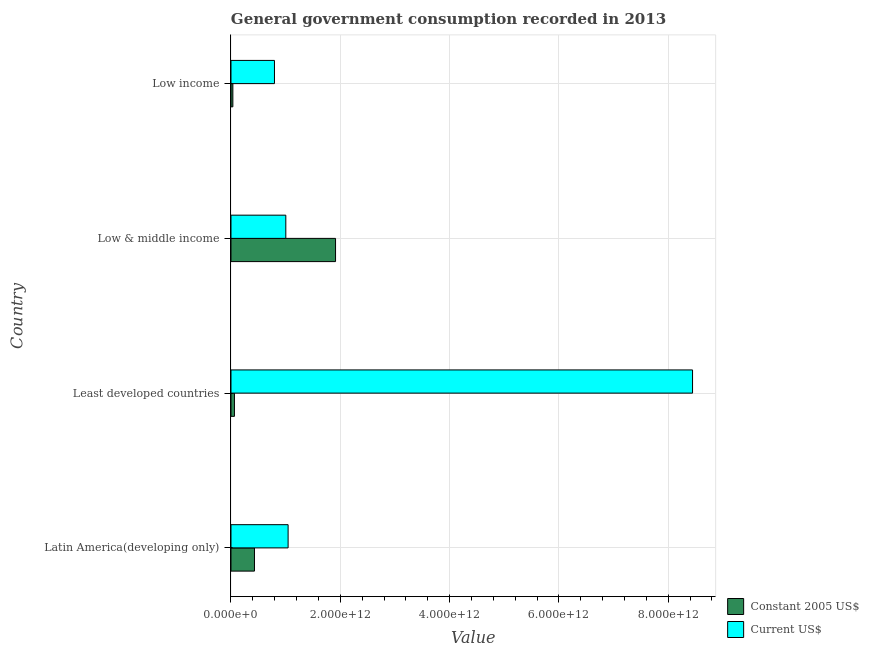Are the number of bars per tick equal to the number of legend labels?
Give a very brief answer. Yes. How many bars are there on the 1st tick from the bottom?
Make the answer very short. 2. What is the label of the 4th group of bars from the top?
Provide a succinct answer. Latin America(developing only). In how many cases, is the number of bars for a given country not equal to the number of legend labels?
Provide a succinct answer. 0. What is the value consumed in constant 2005 us$ in Latin America(developing only)?
Your response must be concise. 4.30e+11. Across all countries, what is the maximum value consumed in constant 2005 us$?
Make the answer very short. 1.91e+12. Across all countries, what is the minimum value consumed in constant 2005 us$?
Offer a very short reply. 3.45e+1. In which country was the value consumed in current us$ maximum?
Give a very brief answer. Least developed countries. What is the total value consumed in constant 2005 us$ in the graph?
Keep it short and to the point. 2.44e+12. What is the difference between the value consumed in current us$ in Latin America(developing only) and that in Low income?
Make the answer very short. 2.50e+11. What is the difference between the value consumed in constant 2005 us$ in Low & middle income and the value consumed in current us$ in Least developed countries?
Provide a short and direct response. -6.53e+12. What is the average value consumed in current us$ per country?
Your answer should be very brief. 2.82e+12. What is the difference between the value consumed in current us$ and value consumed in constant 2005 us$ in Least developed countries?
Your answer should be very brief. 8.38e+12. What is the ratio of the value consumed in current us$ in Least developed countries to that in Low & middle income?
Keep it short and to the point. 8.42. What is the difference between the highest and the second highest value consumed in current us$?
Provide a succinct answer. 7.40e+12. What is the difference between the highest and the lowest value consumed in current us$?
Make the answer very short. 7.65e+12. In how many countries, is the value consumed in current us$ greater than the average value consumed in current us$ taken over all countries?
Make the answer very short. 1. Is the sum of the value consumed in constant 2005 us$ in Low & middle income and Low income greater than the maximum value consumed in current us$ across all countries?
Your answer should be very brief. No. What does the 2nd bar from the top in Least developed countries represents?
Your answer should be very brief. Constant 2005 US$. What does the 1st bar from the bottom in Low & middle income represents?
Make the answer very short. Constant 2005 US$. How many bars are there?
Your response must be concise. 8. How many countries are there in the graph?
Provide a short and direct response. 4. What is the difference between two consecutive major ticks on the X-axis?
Offer a very short reply. 2.00e+12. Are the values on the major ticks of X-axis written in scientific E-notation?
Ensure brevity in your answer.  Yes. Does the graph contain any zero values?
Ensure brevity in your answer.  No. Does the graph contain grids?
Offer a very short reply. Yes. How many legend labels are there?
Your answer should be compact. 2. How are the legend labels stacked?
Give a very brief answer. Vertical. What is the title of the graph?
Offer a terse response. General government consumption recorded in 2013. Does "Broad money growth" appear as one of the legend labels in the graph?
Ensure brevity in your answer.  No. What is the label or title of the X-axis?
Your response must be concise. Value. What is the Value of Constant 2005 US$ in Latin America(developing only)?
Offer a very short reply. 4.30e+11. What is the Value of Current US$ in Latin America(developing only)?
Keep it short and to the point. 1.05e+12. What is the Value in Constant 2005 US$ in Least developed countries?
Make the answer very short. 6.36e+1. What is the Value of Current US$ in Least developed countries?
Keep it short and to the point. 8.45e+12. What is the Value in Constant 2005 US$ in Low & middle income?
Your response must be concise. 1.91e+12. What is the Value in Current US$ in Low & middle income?
Provide a succinct answer. 1.00e+12. What is the Value in Constant 2005 US$ in Low income?
Offer a terse response. 3.45e+1. What is the Value of Current US$ in Low income?
Provide a short and direct response. 7.96e+11. Across all countries, what is the maximum Value of Constant 2005 US$?
Provide a short and direct response. 1.91e+12. Across all countries, what is the maximum Value in Current US$?
Your response must be concise. 8.45e+12. Across all countries, what is the minimum Value in Constant 2005 US$?
Your answer should be compact. 3.45e+1. Across all countries, what is the minimum Value in Current US$?
Provide a succinct answer. 7.96e+11. What is the total Value in Constant 2005 US$ in the graph?
Your response must be concise. 2.44e+12. What is the total Value in Current US$ in the graph?
Ensure brevity in your answer.  1.13e+13. What is the difference between the Value in Constant 2005 US$ in Latin America(developing only) and that in Least developed countries?
Give a very brief answer. 3.66e+11. What is the difference between the Value in Current US$ in Latin America(developing only) and that in Least developed countries?
Offer a very short reply. -7.40e+12. What is the difference between the Value of Constant 2005 US$ in Latin America(developing only) and that in Low & middle income?
Your answer should be compact. -1.48e+12. What is the difference between the Value of Current US$ in Latin America(developing only) and that in Low & middle income?
Your response must be concise. 4.22e+1. What is the difference between the Value in Constant 2005 US$ in Latin America(developing only) and that in Low income?
Your answer should be compact. 3.95e+11. What is the difference between the Value in Current US$ in Latin America(developing only) and that in Low income?
Ensure brevity in your answer.  2.50e+11. What is the difference between the Value of Constant 2005 US$ in Least developed countries and that in Low & middle income?
Provide a short and direct response. -1.85e+12. What is the difference between the Value in Current US$ in Least developed countries and that in Low & middle income?
Offer a terse response. 7.44e+12. What is the difference between the Value of Constant 2005 US$ in Least developed countries and that in Low income?
Keep it short and to the point. 2.91e+1. What is the difference between the Value of Current US$ in Least developed countries and that in Low income?
Make the answer very short. 7.65e+12. What is the difference between the Value of Constant 2005 US$ in Low & middle income and that in Low income?
Your answer should be very brief. 1.88e+12. What is the difference between the Value of Current US$ in Low & middle income and that in Low income?
Give a very brief answer. 2.08e+11. What is the difference between the Value in Constant 2005 US$ in Latin America(developing only) and the Value in Current US$ in Least developed countries?
Your response must be concise. -8.02e+12. What is the difference between the Value of Constant 2005 US$ in Latin America(developing only) and the Value of Current US$ in Low & middle income?
Keep it short and to the point. -5.73e+11. What is the difference between the Value in Constant 2005 US$ in Latin America(developing only) and the Value in Current US$ in Low income?
Make the answer very short. -3.66e+11. What is the difference between the Value of Constant 2005 US$ in Least developed countries and the Value of Current US$ in Low & middle income?
Keep it short and to the point. -9.40e+11. What is the difference between the Value of Constant 2005 US$ in Least developed countries and the Value of Current US$ in Low income?
Provide a succinct answer. -7.32e+11. What is the difference between the Value of Constant 2005 US$ in Low & middle income and the Value of Current US$ in Low income?
Keep it short and to the point. 1.12e+12. What is the average Value of Constant 2005 US$ per country?
Provide a succinct answer. 6.10e+11. What is the average Value in Current US$ per country?
Your answer should be very brief. 2.82e+12. What is the difference between the Value of Constant 2005 US$ and Value of Current US$ in Latin America(developing only)?
Provide a succinct answer. -6.16e+11. What is the difference between the Value of Constant 2005 US$ and Value of Current US$ in Least developed countries?
Your answer should be compact. -8.38e+12. What is the difference between the Value in Constant 2005 US$ and Value in Current US$ in Low & middle income?
Offer a terse response. 9.10e+11. What is the difference between the Value in Constant 2005 US$ and Value in Current US$ in Low income?
Keep it short and to the point. -7.61e+11. What is the ratio of the Value of Constant 2005 US$ in Latin America(developing only) to that in Least developed countries?
Make the answer very short. 6.76. What is the ratio of the Value of Current US$ in Latin America(developing only) to that in Least developed countries?
Offer a terse response. 0.12. What is the ratio of the Value of Constant 2005 US$ in Latin America(developing only) to that in Low & middle income?
Your response must be concise. 0.22. What is the ratio of the Value of Current US$ in Latin America(developing only) to that in Low & middle income?
Your answer should be compact. 1.04. What is the ratio of the Value of Constant 2005 US$ in Latin America(developing only) to that in Low income?
Your response must be concise. 12.47. What is the ratio of the Value of Current US$ in Latin America(developing only) to that in Low income?
Your answer should be very brief. 1.31. What is the ratio of the Value in Constant 2005 US$ in Least developed countries to that in Low & middle income?
Ensure brevity in your answer.  0.03. What is the ratio of the Value in Current US$ in Least developed countries to that in Low & middle income?
Keep it short and to the point. 8.42. What is the ratio of the Value of Constant 2005 US$ in Least developed countries to that in Low income?
Ensure brevity in your answer.  1.84. What is the ratio of the Value in Current US$ in Least developed countries to that in Low income?
Your answer should be very brief. 10.61. What is the ratio of the Value of Constant 2005 US$ in Low & middle income to that in Low income?
Provide a short and direct response. 55.49. What is the ratio of the Value of Current US$ in Low & middle income to that in Low income?
Your response must be concise. 1.26. What is the difference between the highest and the second highest Value in Constant 2005 US$?
Your answer should be very brief. 1.48e+12. What is the difference between the highest and the second highest Value of Current US$?
Your response must be concise. 7.40e+12. What is the difference between the highest and the lowest Value of Constant 2005 US$?
Your answer should be very brief. 1.88e+12. What is the difference between the highest and the lowest Value in Current US$?
Provide a succinct answer. 7.65e+12. 